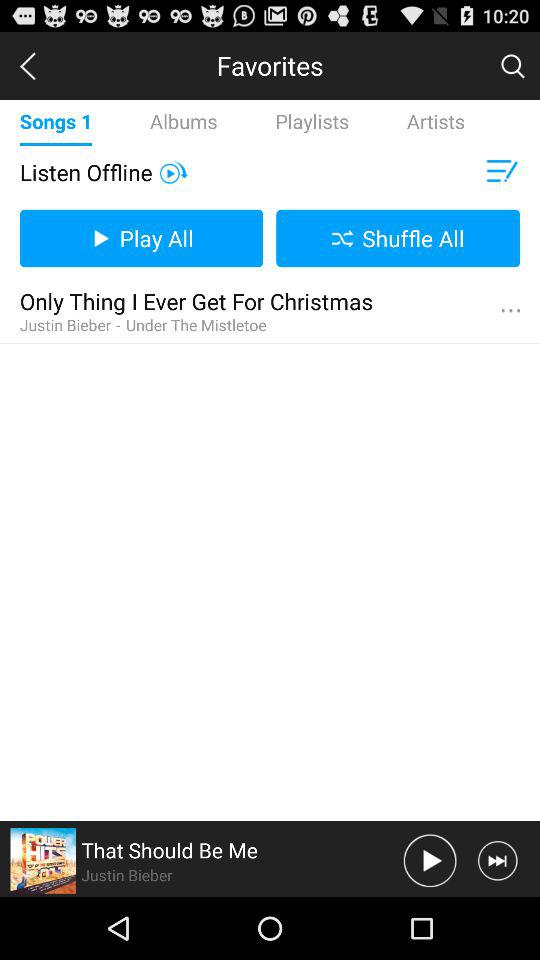Who is the singer of the song "That Should Be Me"? The singer of the song "That Should Be Me" is Justin Bieber. 